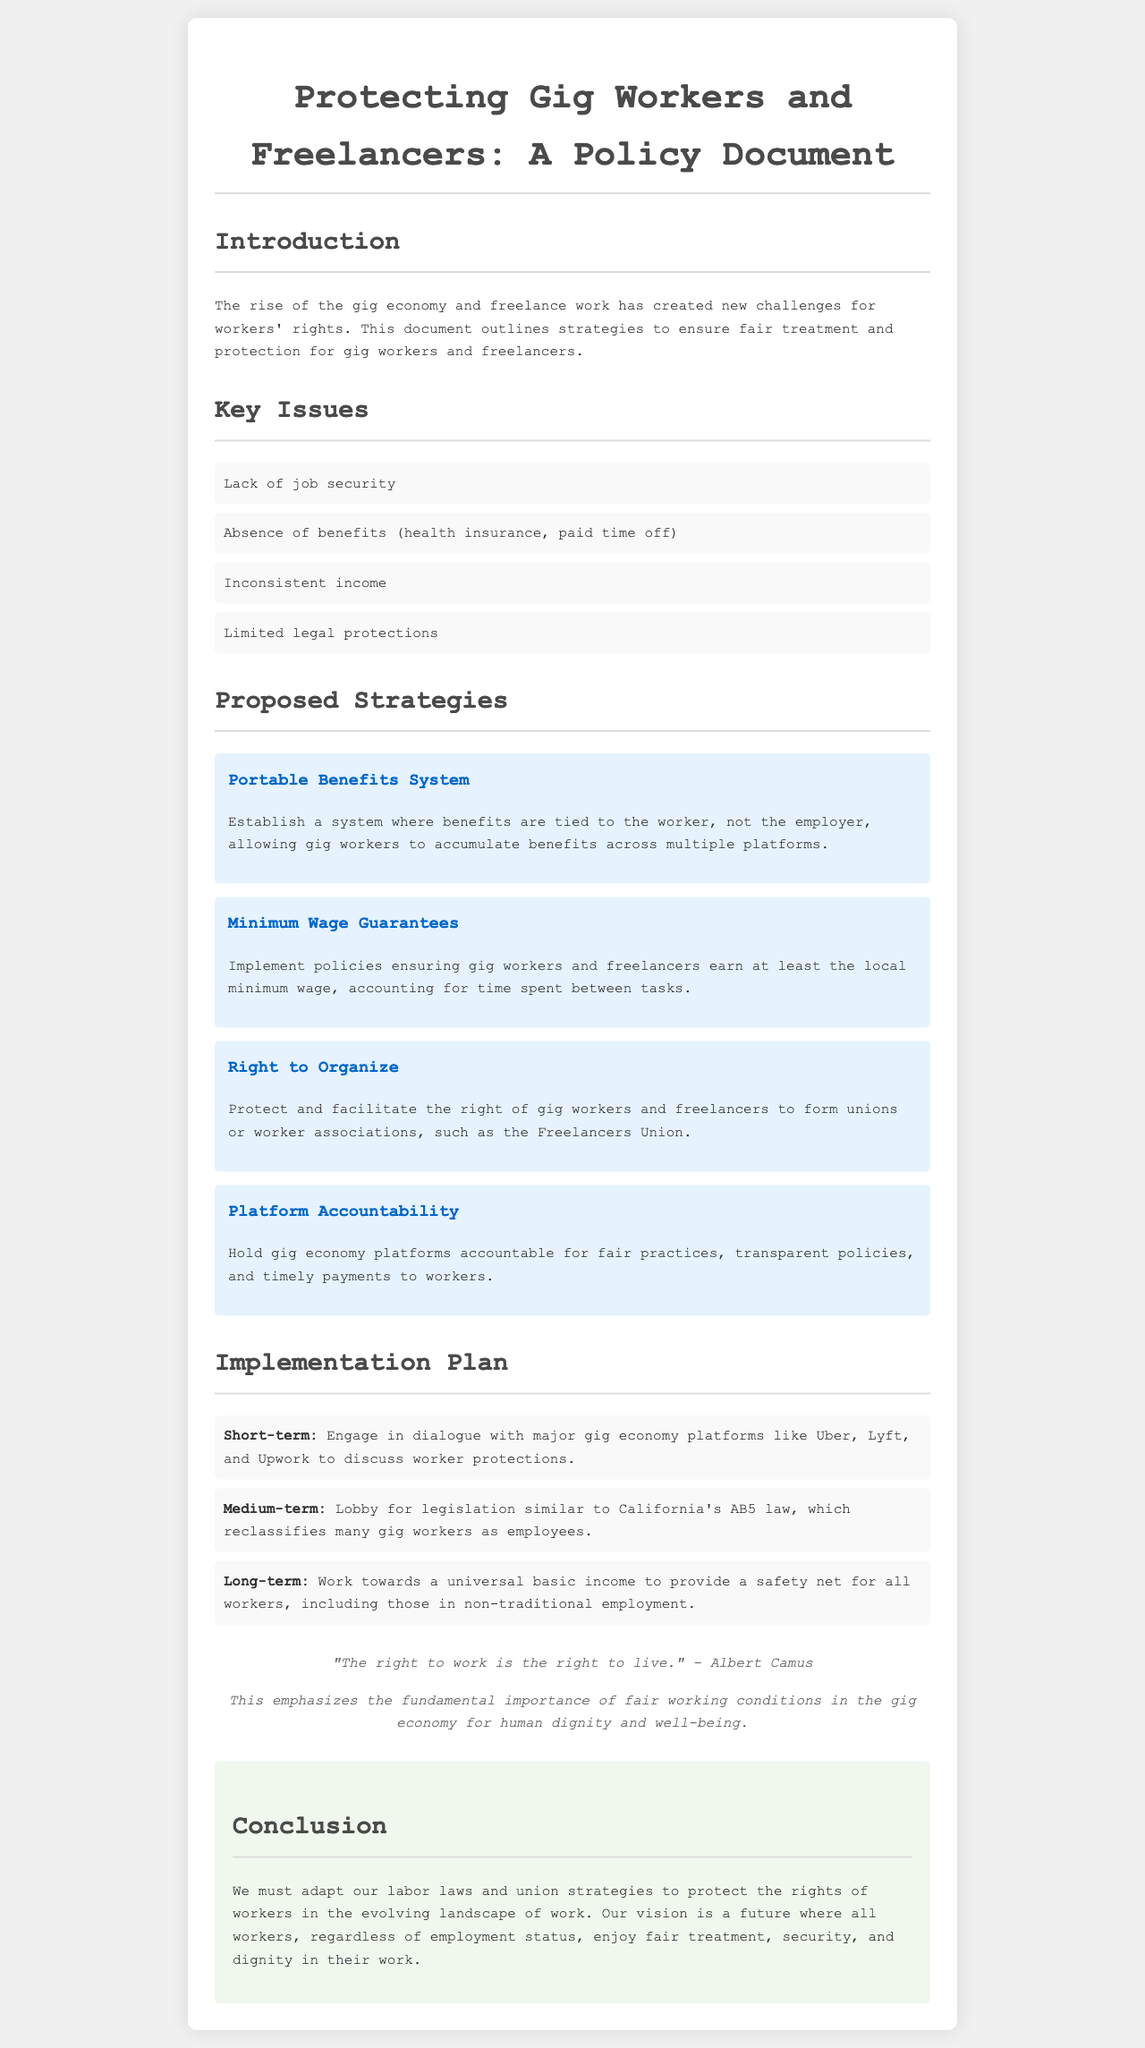What is the title of the policy document? The title is specified in the heading of the document.
Answer: Protecting Gig Workers and Freelancers: A Policy Document What are two key issues faced by gig workers? The document lists multiple key issues; the question asks for two of them.
Answer: Lack of job security, Absence of benefits What is one proposed strategy for protecting gig workers? The document outlines several strategies; this asks for one example.
Answer: Portable Benefits System What legislation is mentioned in the implementation plan? The document specifically references a piece of legislation relevant to gig workers.
Answer: California's AB5 law Who is quoted in the document? The document includes a quote from a notable figure related to work rights.
Answer: Albert Camus How does the document propose to engage with gig economy platforms? The document specifies a short-term plan regarding engagement.
Answer: Dialogue What long-term goal is mentioned in the conclusion? The conclusion summarizes the vision for future worker protections.
Answer: Universal basic income What does the "Right to Organize" strategy aim to achieve? This strategy is intended to protect a specific worker's right mentioned in the document.
Answer: Form unions or worker associations 